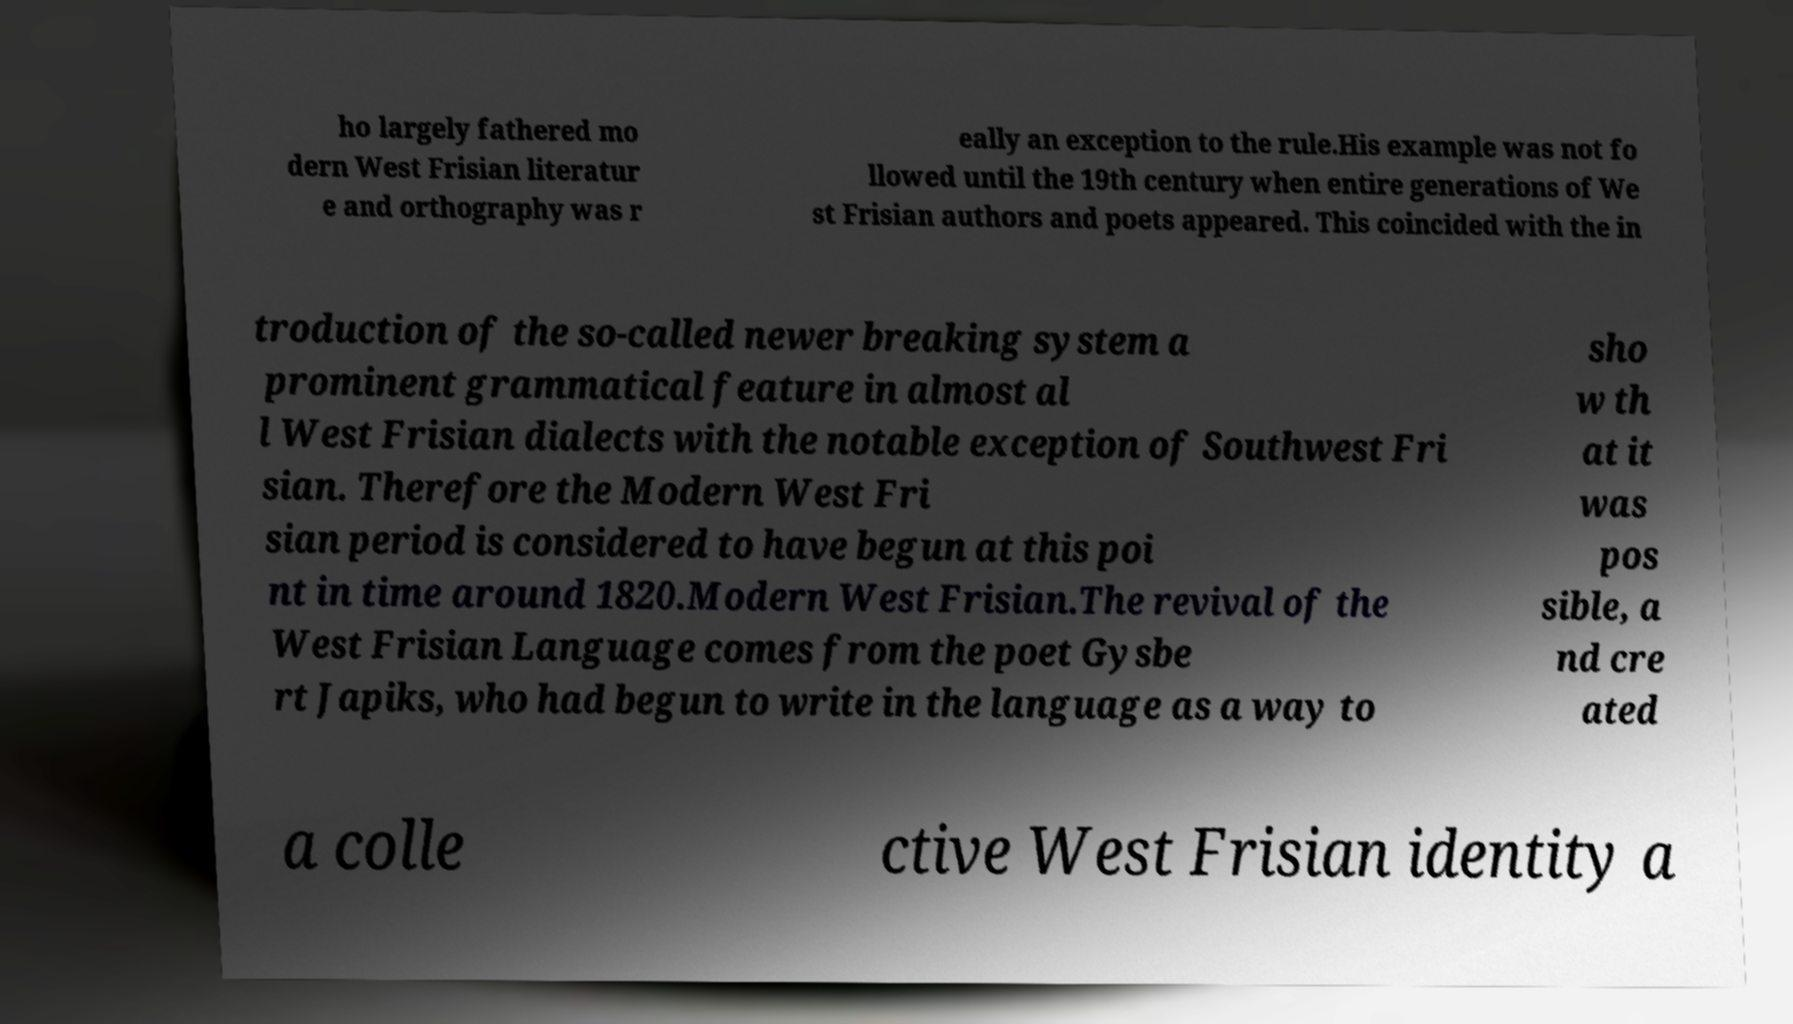Can you read and provide the text displayed in the image?This photo seems to have some interesting text. Can you extract and type it out for me? ho largely fathered mo dern West Frisian literatur e and orthography was r eally an exception to the rule.His example was not fo llowed until the 19th century when entire generations of We st Frisian authors and poets appeared. This coincided with the in troduction of the so-called newer breaking system a prominent grammatical feature in almost al l West Frisian dialects with the notable exception of Southwest Fri sian. Therefore the Modern West Fri sian period is considered to have begun at this poi nt in time around 1820.Modern West Frisian.The revival of the West Frisian Language comes from the poet Gysbe rt Japiks, who had begun to write in the language as a way to sho w th at it was pos sible, a nd cre ated a colle ctive West Frisian identity a 